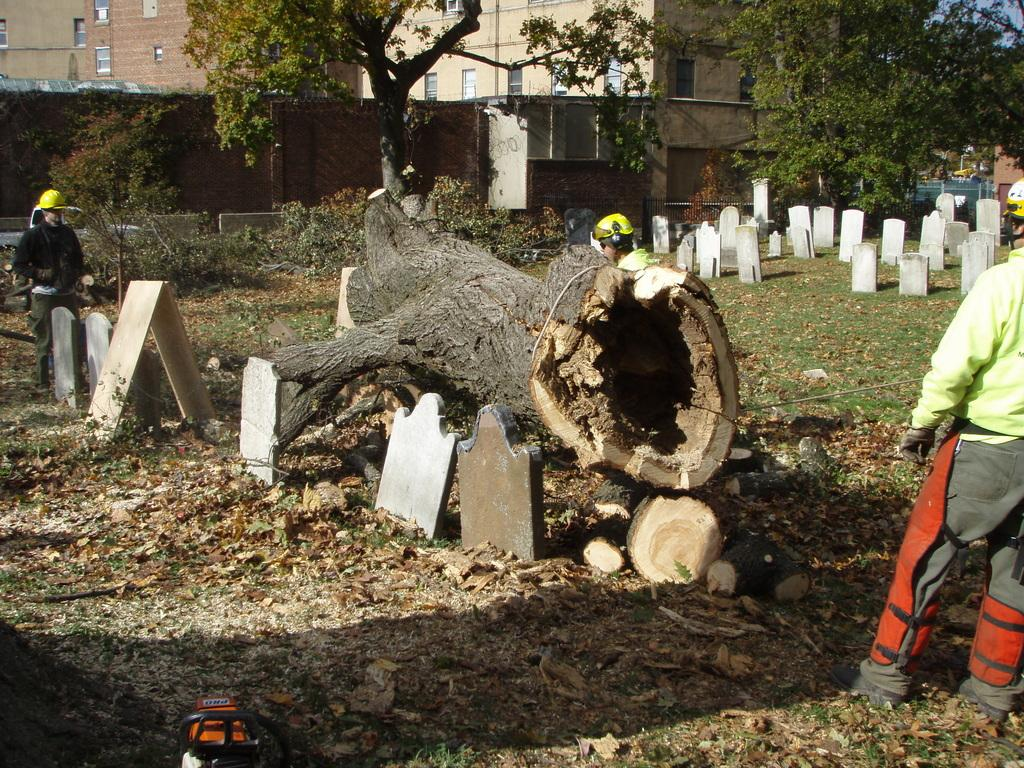What type of location is depicted in the image? The image contains cemeteries. What can be seen in the foreground of the image? There is a tree trunk in the image. What is the surrounding environment like in the image? There are trees surrounding the area in the image. Are there any other individuals present in the image? Yes, there are other people in the image. What type of adjustment is being made by the tree in the image? There is no indication in the image that the tree is making any adjustments. 